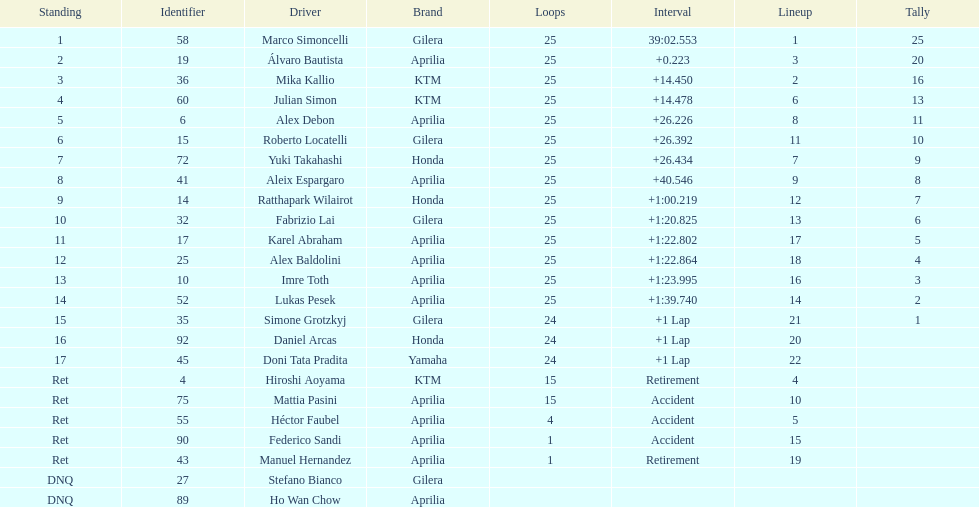What is the total number of rider? 24. 